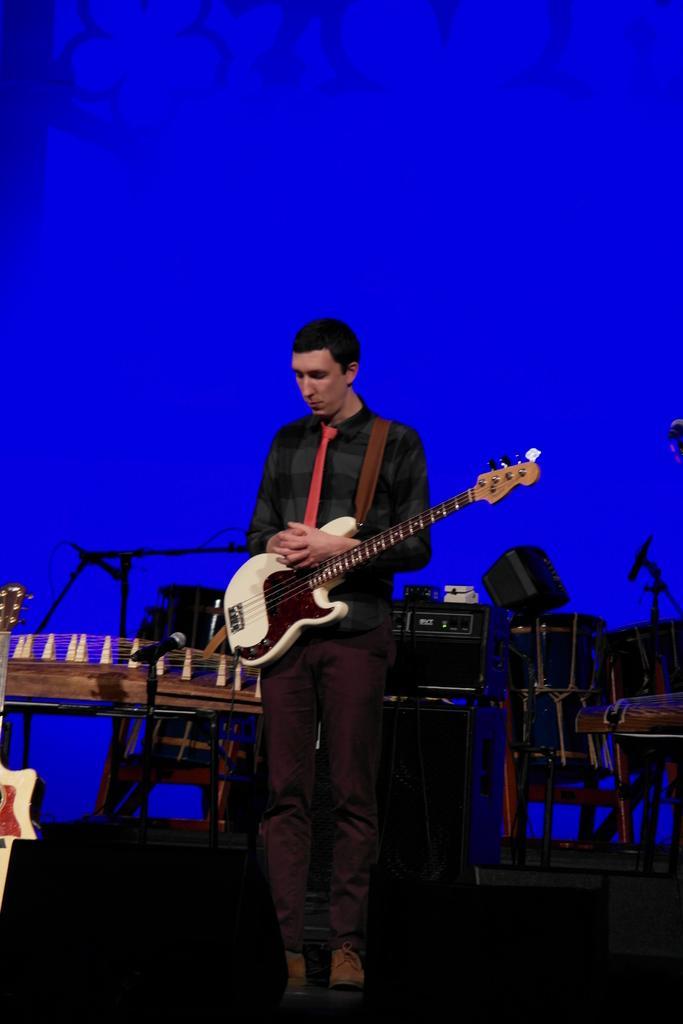Describe this image in one or two sentences. This image is clicked in a musical concert. There is a person standing in the middle, he has guitar with him. Behind him there are so many musical instruments. He is wearing shoes and tie. He is wearing black dress. 